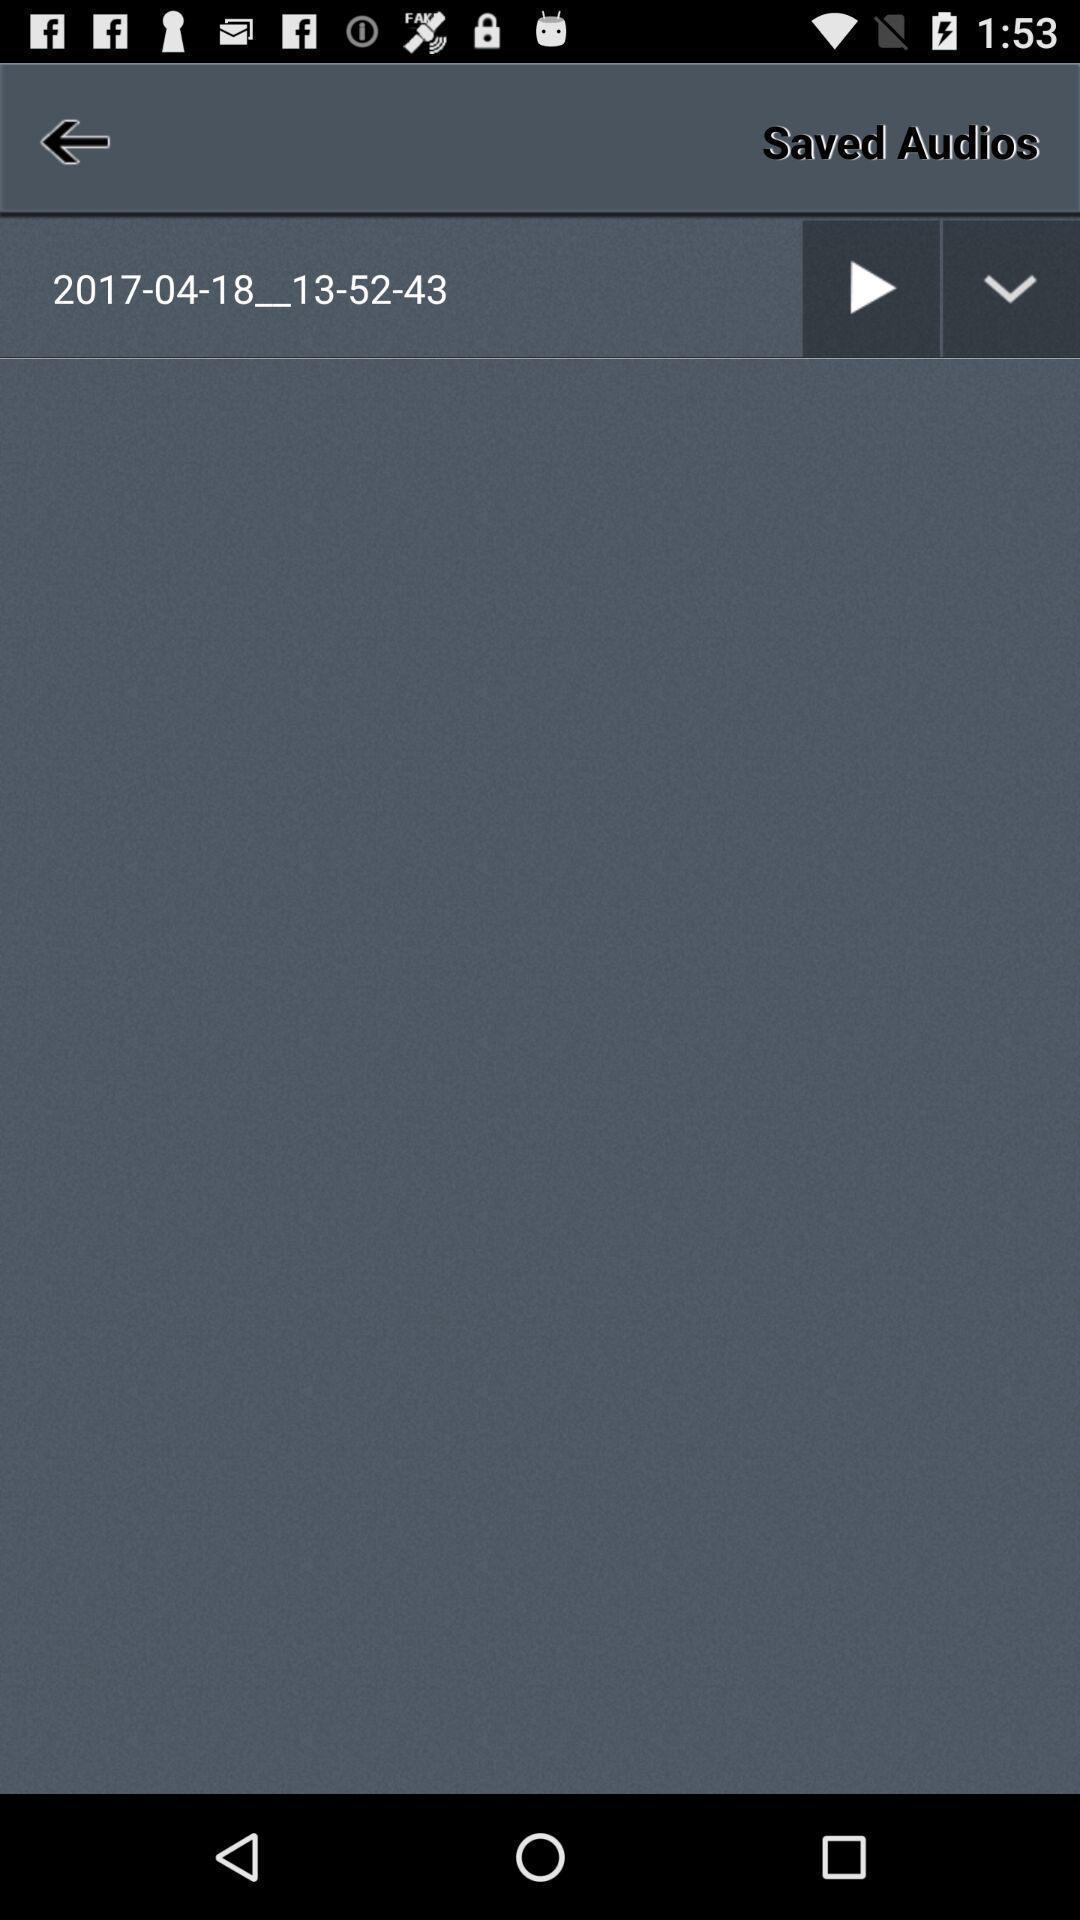Explain what's happening in this screen capture. Screen showing saved audio. 